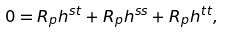Convert formula to latex. <formula><loc_0><loc_0><loc_500><loc_500>0 = R _ { p } h ^ { s t } + R _ { p } h ^ { s s } + R _ { p } h ^ { t t } ,</formula> 